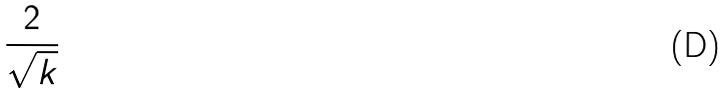Convert formula to latex. <formula><loc_0><loc_0><loc_500><loc_500>\frac { 2 } { \sqrt { k } }</formula> 